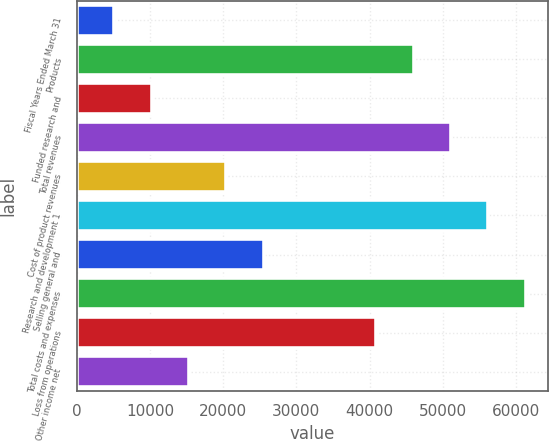Convert chart to OTSL. <chart><loc_0><loc_0><loc_500><loc_500><bar_chart><fcel>Fiscal Years Ended March 31<fcel>Products<fcel>Funded research and<fcel>Total revenues<fcel>Cost of product revenues<fcel>Research and development 1<fcel>Selling general and<fcel>Total costs and expenses<fcel>Loss from operations<fcel>Other income net<nl><fcel>5110.82<fcel>45989.2<fcel>10220.6<fcel>51099<fcel>20440.2<fcel>56208.8<fcel>25550<fcel>61318.6<fcel>40879.4<fcel>15330.4<nl></chart> 